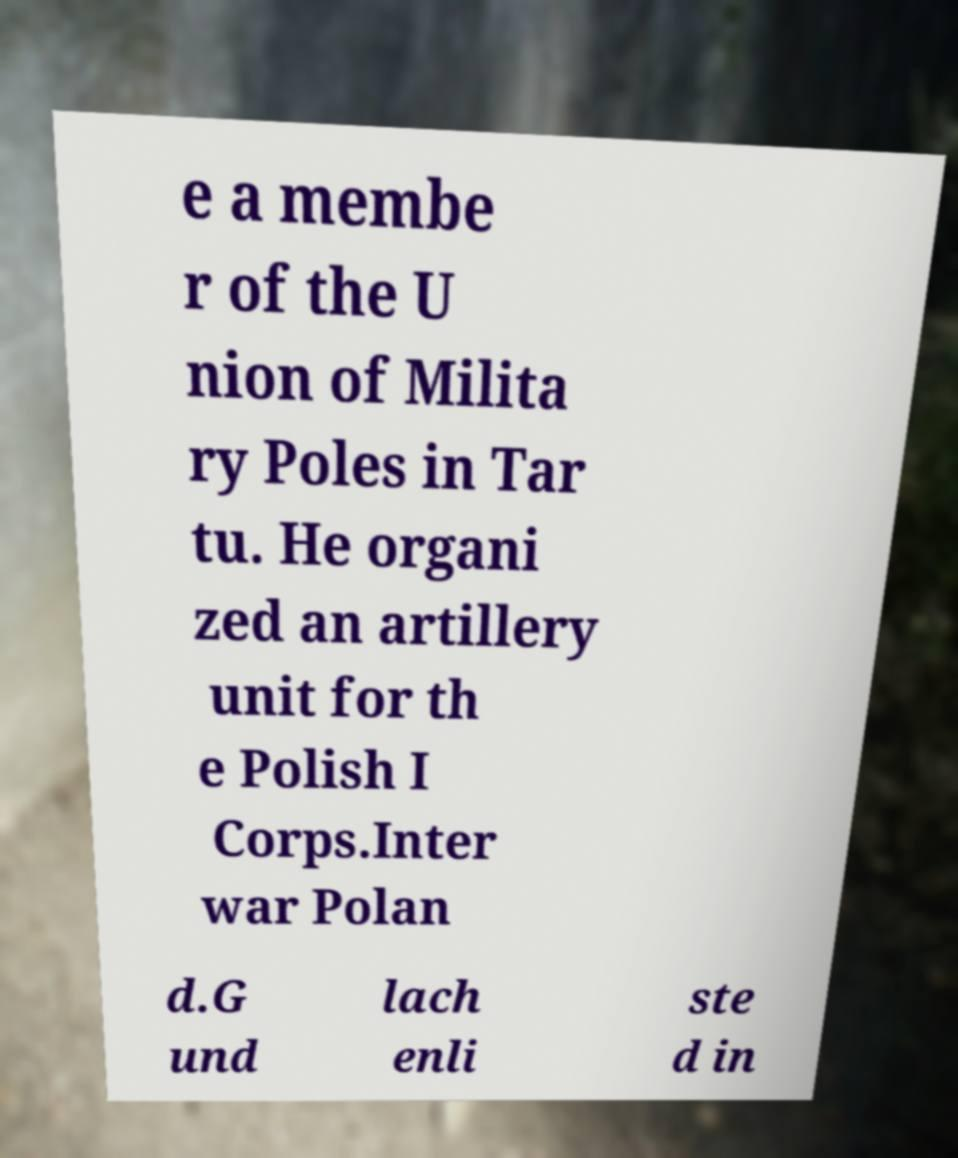For documentation purposes, I need the text within this image transcribed. Could you provide that? e a membe r of the U nion of Milita ry Poles in Tar tu. He organi zed an artillery unit for th e Polish I Corps.Inter war Polan d.G und lach enli ste d in 